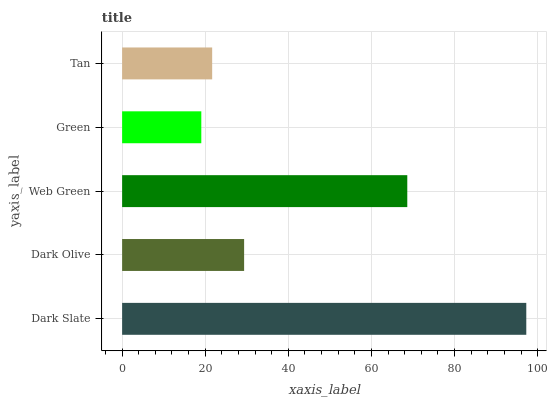Is Green the minimum?
Answer yes or no. Yes. Is Dark Slate the maximum?
Answer yes or no. Yes. Is Dark Olive the minimum?
Answer yes or no. No. Is Dark Olive the maximum?
Answer yes or no. No. Is Dark Slate greater than Dark Olive?
Answer yes or no. Yes. Is Dark Olive less than Dark Slate?
Answer yes or no. Yes. Is Dark Olive greater than Dark Slate?
Answer yes or no. No. Is Dark Slate less than Dark Olive?
Answer yes or no. No. Is Dark Olive the high median?
Answer yes or no. Yes. Is Dark Olive the low median?
Answer yes or no. Yes. Is Green the high median?
Answer yes or no. No. Is Dark Slate the low median?
Answer yes or no. No. 